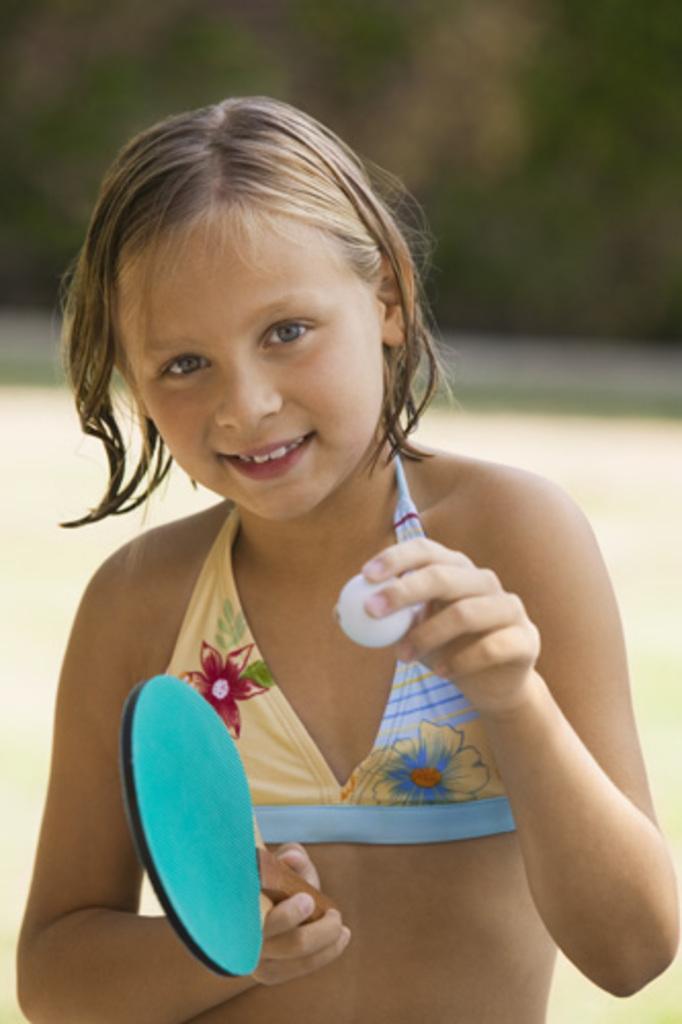Can you describe this image briefly? In this picture we can see a girl holding a tennis bat in one hand and a ball in another hand. 